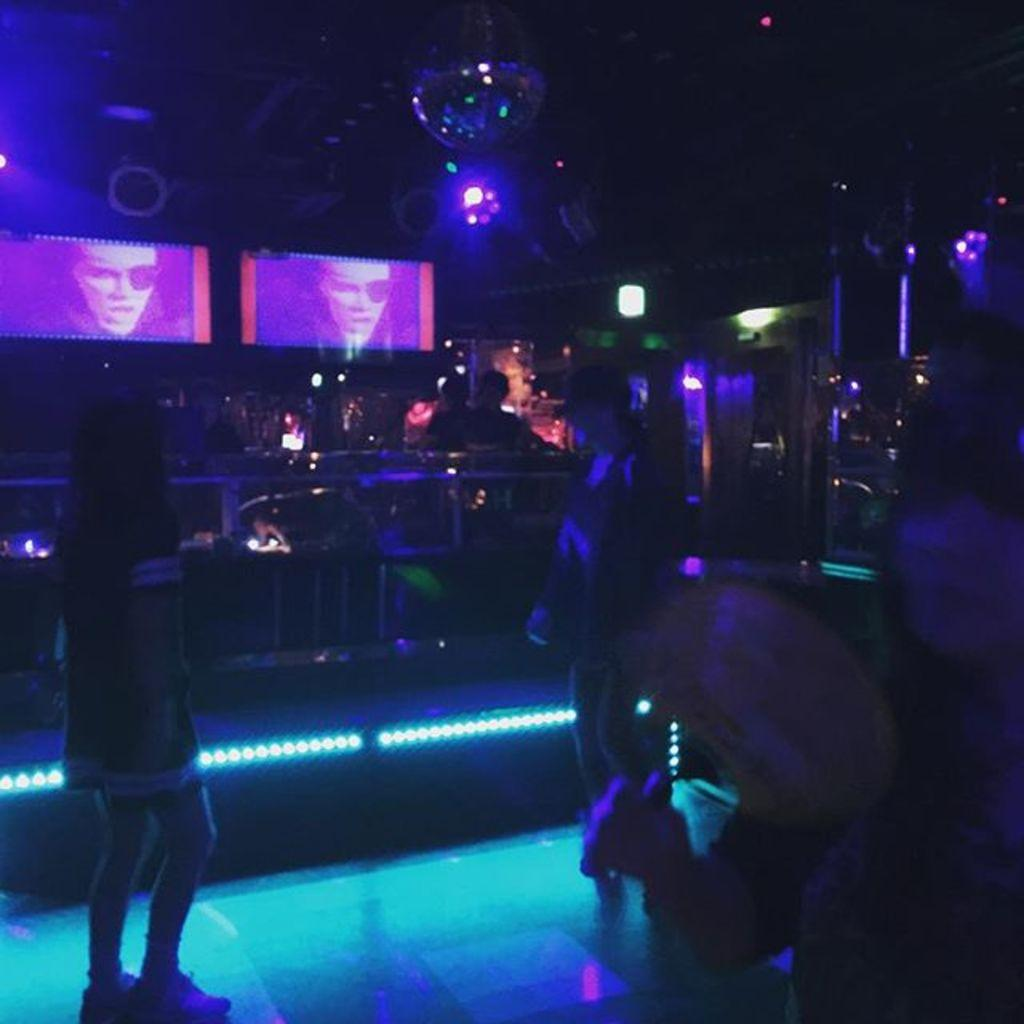What can be seen in the image involving people? There are people standing in the image. Where are the people standing? The people are standing on the floor. What type of equipment is visible in the image? There are two projectors visible in the image. What type of lighting is present in the image? There are ceiling lights in the image. What type of hen can be seen in the image? There is no hen present in the image. How many letters are being passed between the people in the image? There is no mention of letters being passed between the people in the image. 